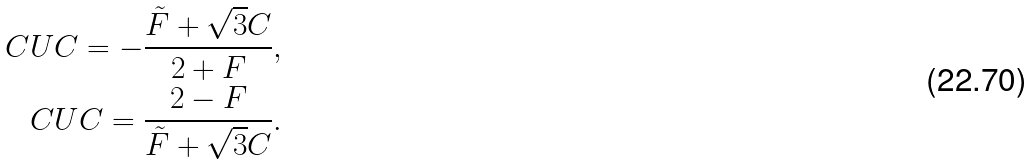Convert formula to latex. <formula><loc_0><loc_0><loc_500><loc_500>C U C = - \frac { \tilde { F } + \sqrt { 3 } C } { 2 + F } , \\ C U C = \frac { 2 - F } { \tilde { F } + \sqrt { 3 } C } .</formula> 